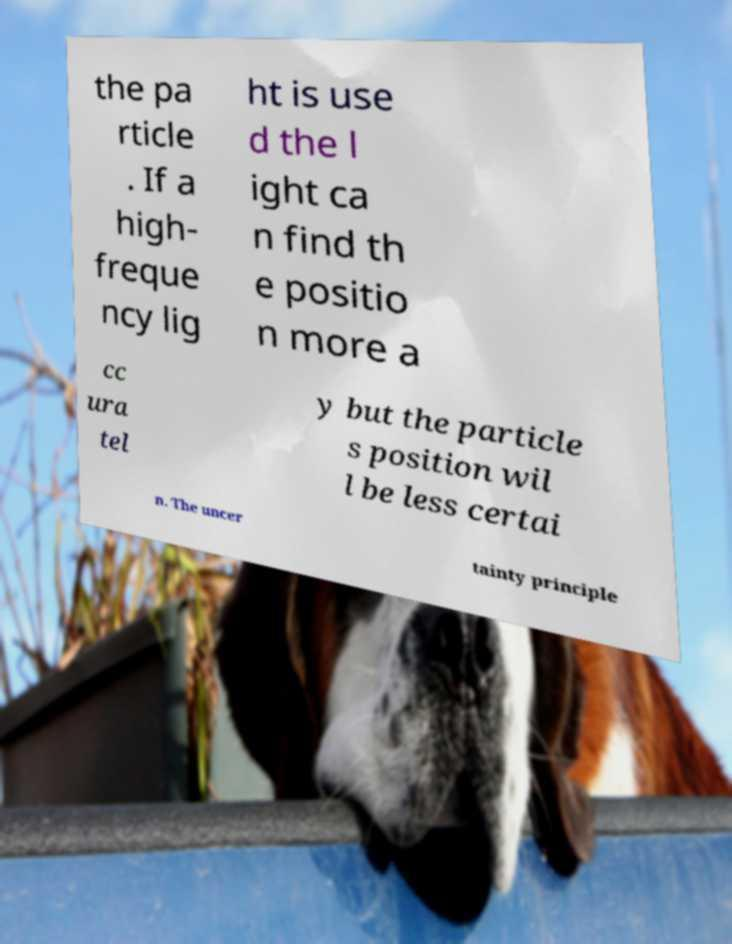Please identify and transcribe the text found in this image. the pa rticle . If a high- freque ncy lig ht is use d the l ight ca n find th e positio n more a cc ura tel y but the particle s position wil l be less certai n. The uncer tainty principle 